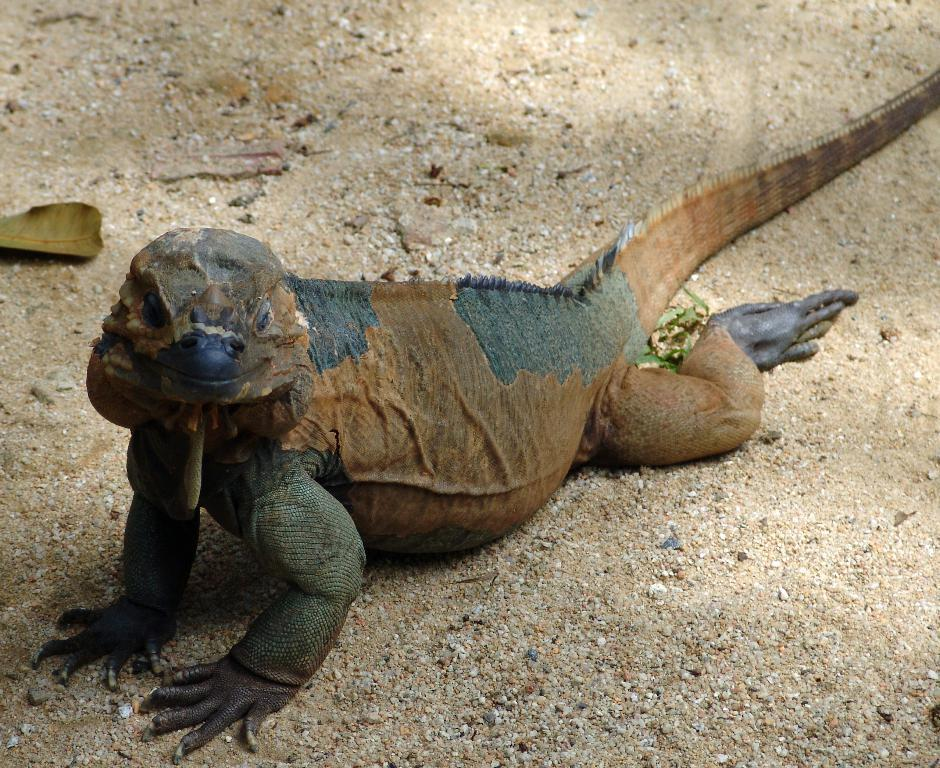What type of animals can be seen in the picture? There are reptiles in the picture. Where are the reptiles located in the image? The reptiles are on the ground. What type of vegetation or debris is visible in the image? There are dry leaves visible in the image. What type of star can be seen shining in the image? There is no star visible in the image; it features reptiles on the ground and dry leaves. 